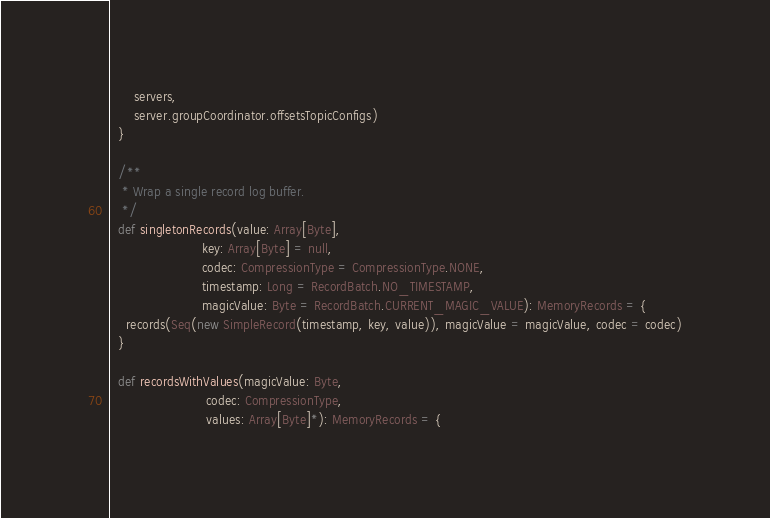Convert code to text. <code><loc_0><loc_0><loc_500><loc_500><_Scala_>      servers,
      server.groupCoordinator.offsetsTopicConfigs)
  }

  /**
   * Wrap a single record log buffer.
   */
  def singletonRecords(value: Array[Byte],
                       key: Array[Byte] = null,
                       codec: CompressionType = CompressionType.NONE,
                       timestamp: Long = RecordBatch.NO_TIMESTAMP,
                       magicValue: Byte = RecordBatch.CURRENT_MAGIC_VALUE): MemoryRecords = {
    records(Seq(new SimpleRecord(timestamp, key, value)), magicValue = magicValue, codec = codec)
  }

  def recordsWithValues(magicValue: Byte,
                        codec: CompressionType,
                        values: Array[Byte]*): MemoryRecords = {</code> 